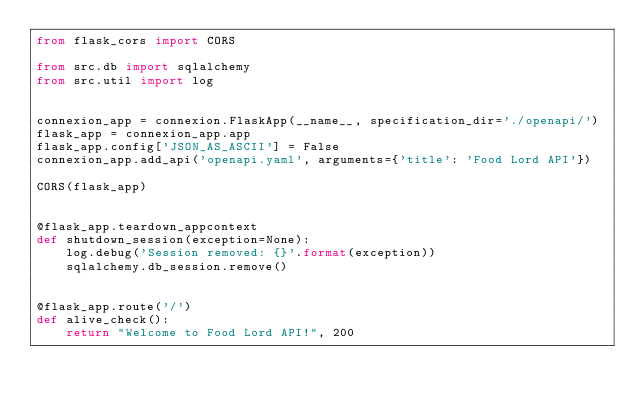Convert code to text. <code><loc_0><loc_0><loc_500><loc_500><_Python_>from flask_cors import CORS

from src.db import sqlalchemy
from src.util import log


connexion_app = connexion.FlaskApp(__name__, specification_dir='./openapi/')
flask_app = connexion_app.app
flask_app.config['JSON_AS_ASCII'] = False
connexion_app.add_api('openapi.yaml', arguments={'title': 'Food Lord API'})

CORS(flask_app)


@flask_app.teardown_appcontext
def shutdown_session(exception=None):
    log.debug('Session removed: {}'.format(exception))
    sqlalchemy.db_session.remove()


@flask_app.route('/')
def alive_check():
    return "Welcome to Food Lord API!", 200
</code> 